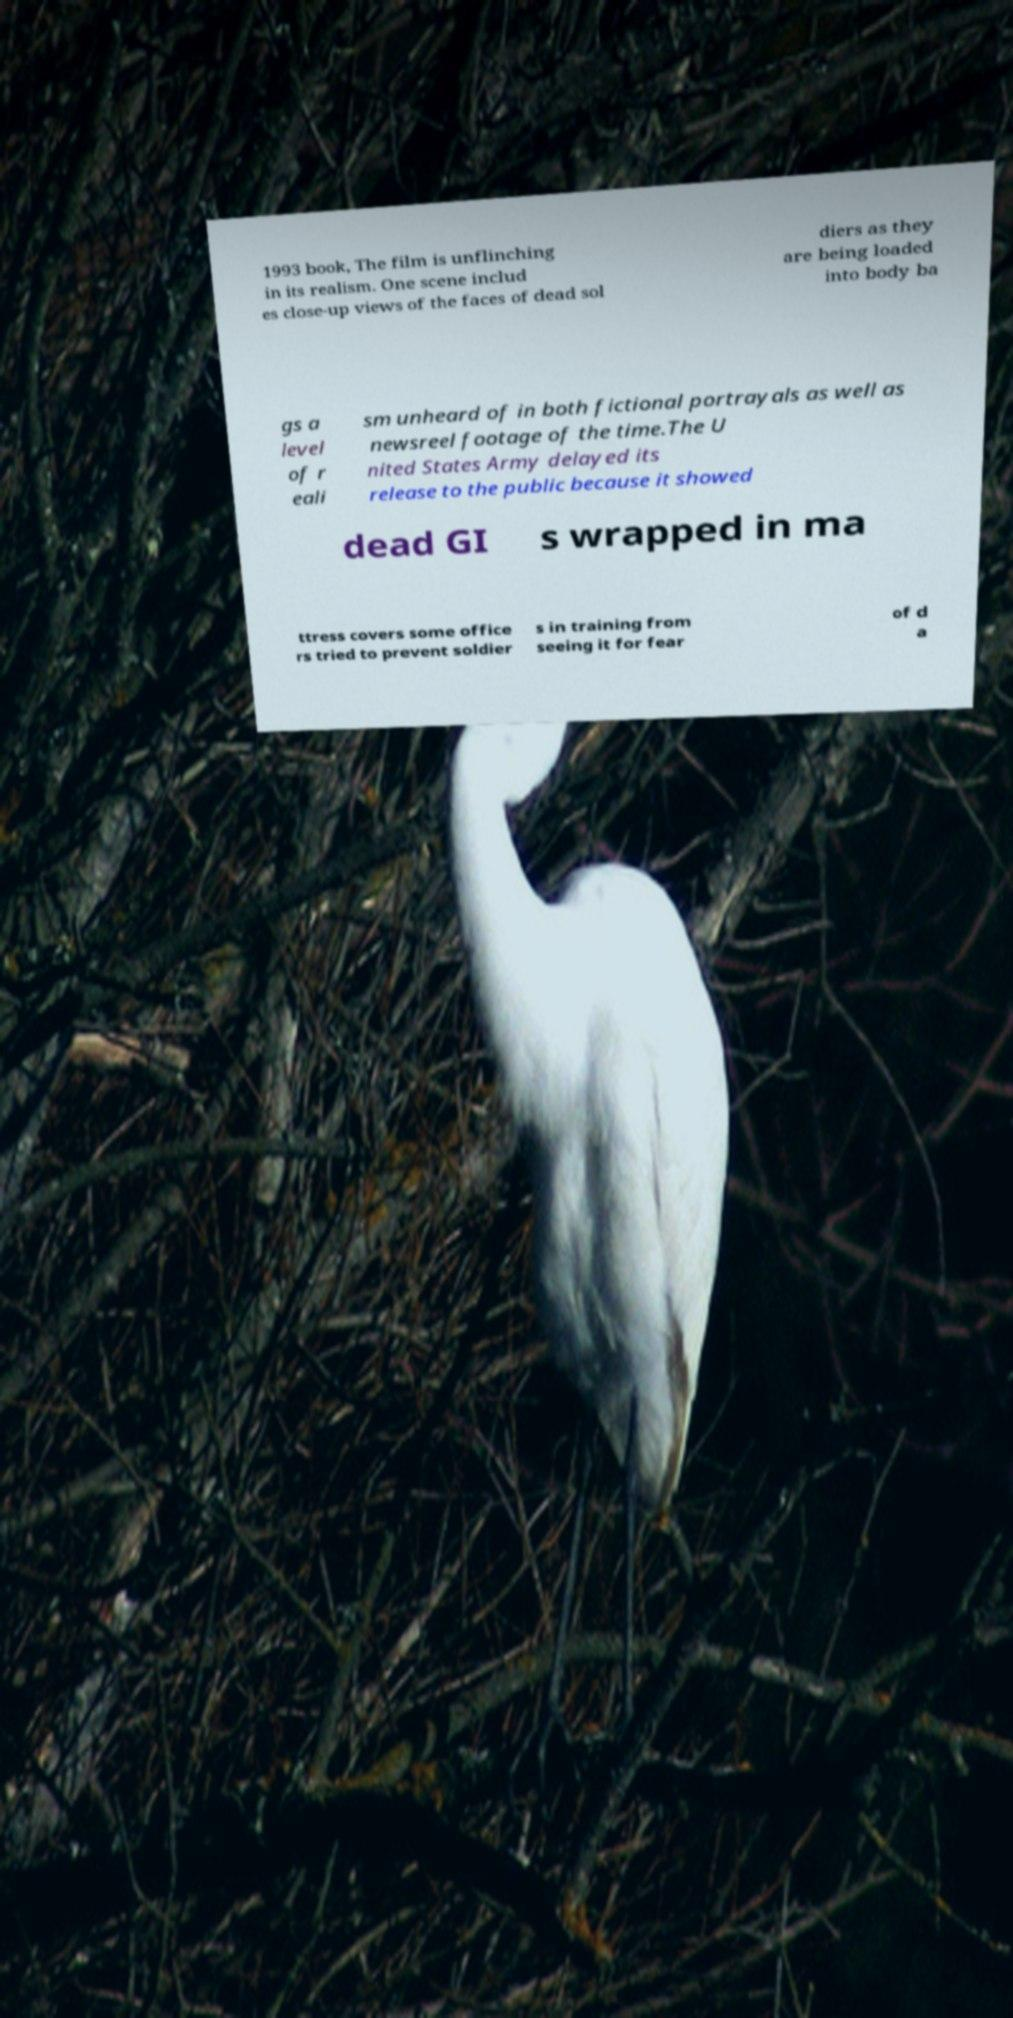For documentation purposes, I need the text within this image transcribed. Could you provide that? 1993 book, The film is unflinching in its realism. One scene includ es close-up views of the faces of dead sol diers as they are being loaded into body ba gs a level of r eali sm unheard of in both fictional portrayals as well as newsreel footage of the time.The U nited States Army delayed its release to the public because it showed dead GI s wrapped in ma ttress covers some office rs tried to prevent soldier s in training from seeing it for fear of d a 